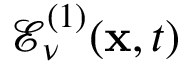Convert formula to latex. <formula><loc_0><loc_0><loc_500><loc_500>\mathcal { E } _ { \nu } ^ { ( 1 ) } ( x , t )</formula> 